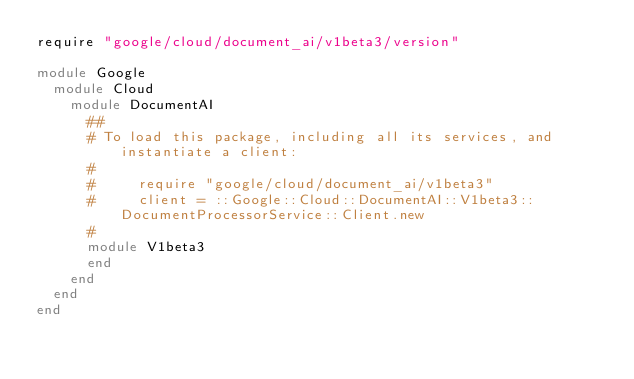<code> <loc_0><loc_0><loc_500><loc_500><_Ruby_>require "google/cloud/document_ai/v1beta3/version"

module Google
  module Cloud
    module DocumentAI
      ##
      # To load this package, including all its services, and instantiate a client:
      #
      #     require "google/cloud/document_ai/v1beta3"
      #     client = ::Google::Cloud::DocumentAI::V1beta3::DocumentProcessorService::Client.new
      #
      module V1beta3
      end
    end
  end
end
</code> 